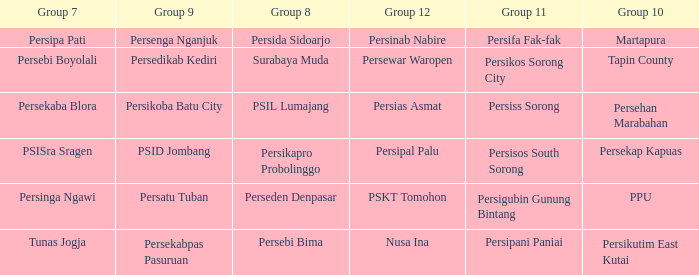When  persikos sorong city played in group 11, who played in group 7? Persebi Boyolali. 